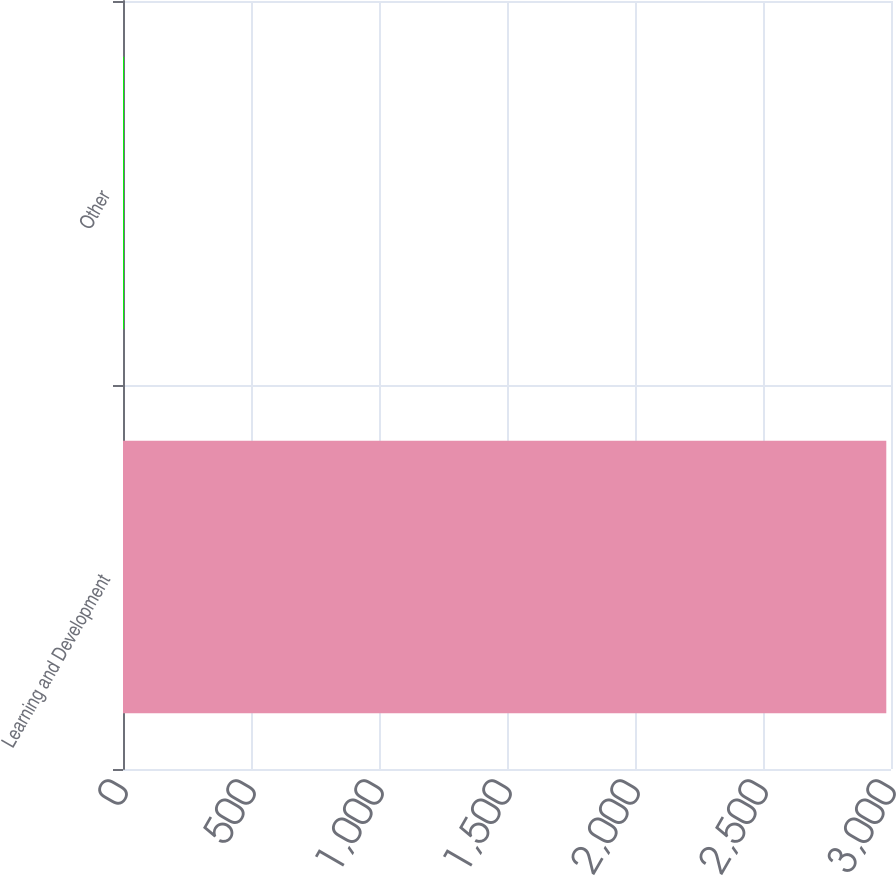Convert chart to OTSL. <chart><loc_0><loc_0><loc_500><loc_500><bar_chart><fcel>Learning and Development<fcel>Other<nl><fcel>2981.6<fcel>3.5<nl></chart> 